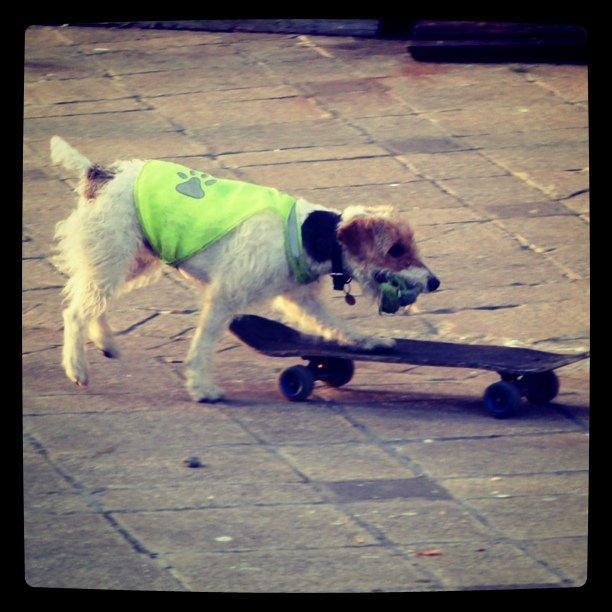How many baby elephants are there?
Give a very brief answer. 0. 